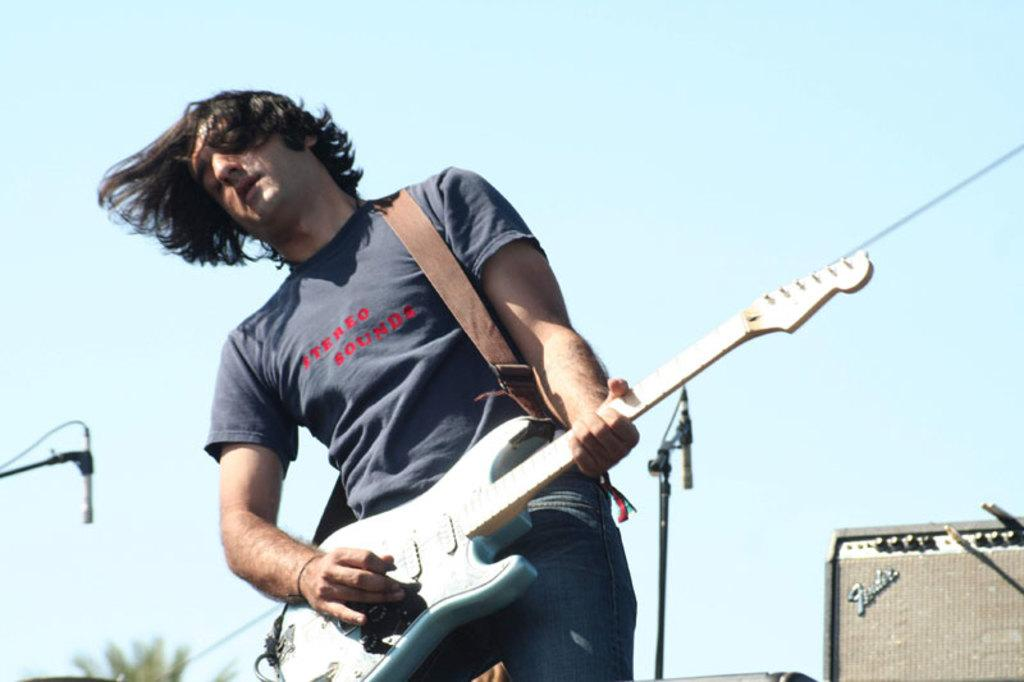What is the main subject of the image? There is a guy in the image. What is the guy doing in the image? The guy is playing a guitar. What objects are present in the image that might be related to the guy's activity? There are speakers in the image. What can be seen in the background of the image? The sky is visible in the image. Can you see any magic happening in the image? There is no magic present in the image. What type of leg is visible in the image? There is no leg mentioned or visible in the image. 